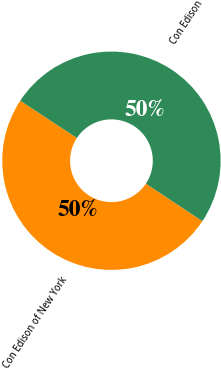Convert chart. <chart><loc_0><loc_0><loc_500><loc_500><pie_chart><fcel>Con Edison of New York<fcel>Con Edison<nl><fcel>49.93%<fcel>50.07%<nl></chart> 